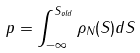<formula> <loc_0><loc_0><loc_500><loc_500>p = \int _ { - \infty } ^ { S _ { o l d } } { \rho } _ { N } ( S ) d S</formula> 